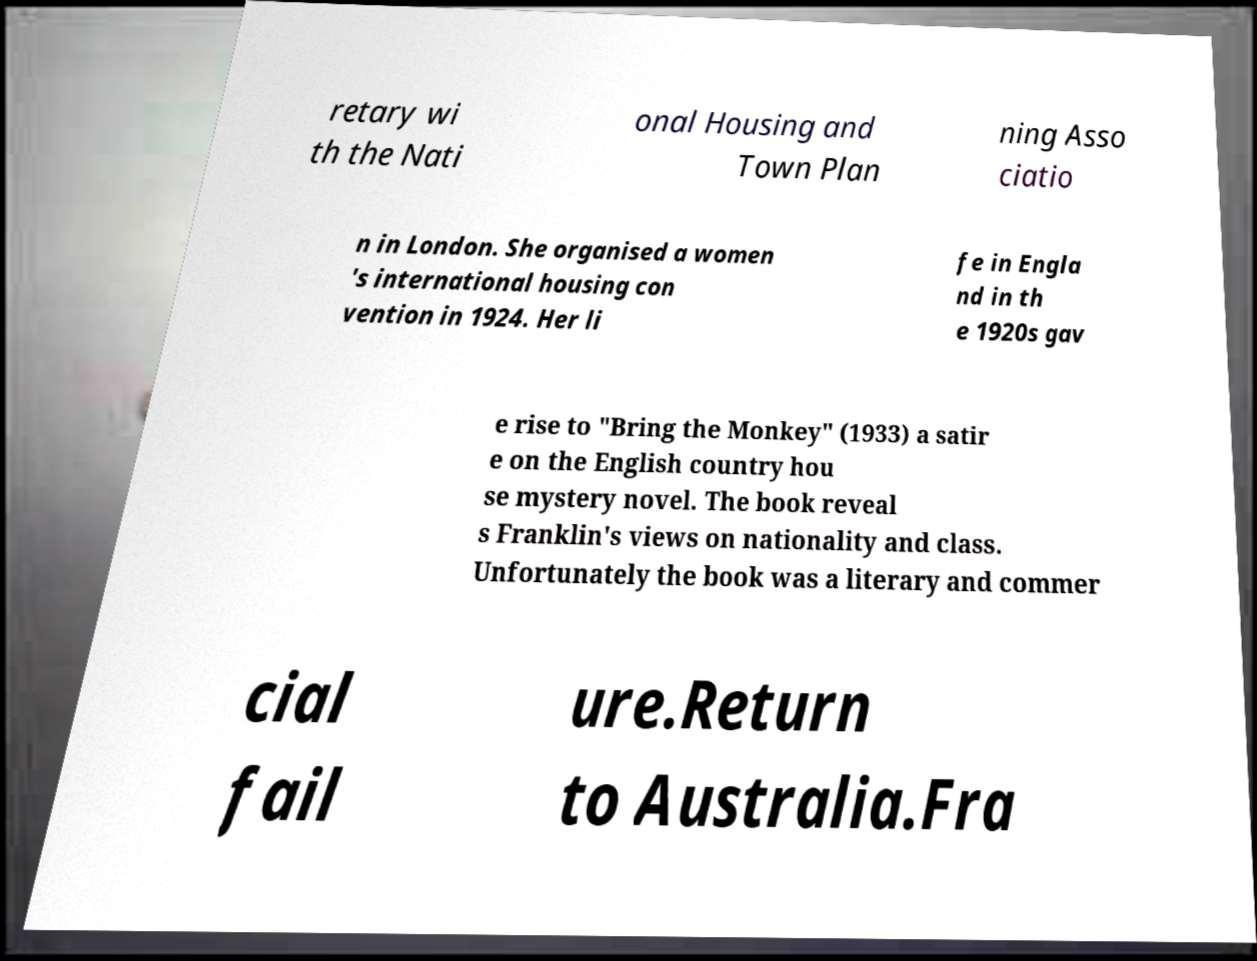Can you read and provide the text displayed in the image?This photo seems to have some interesting text. Can you extract and type it out for me? retary wi th the Nati onal Housing and Town Plan ning Asso ciatio n in London. She organised a women 's international housing con vention in 1924. Her li fe in Engla nd in th e 1920s gav e rise to "Bring the Monkey" (1933) a satir e on the English country hou se mystery novel. The book reveal s Franklin's views on nationality and class. Unfortunately the book was a literary and commer cial fail ure.Return to Australia.Fra 